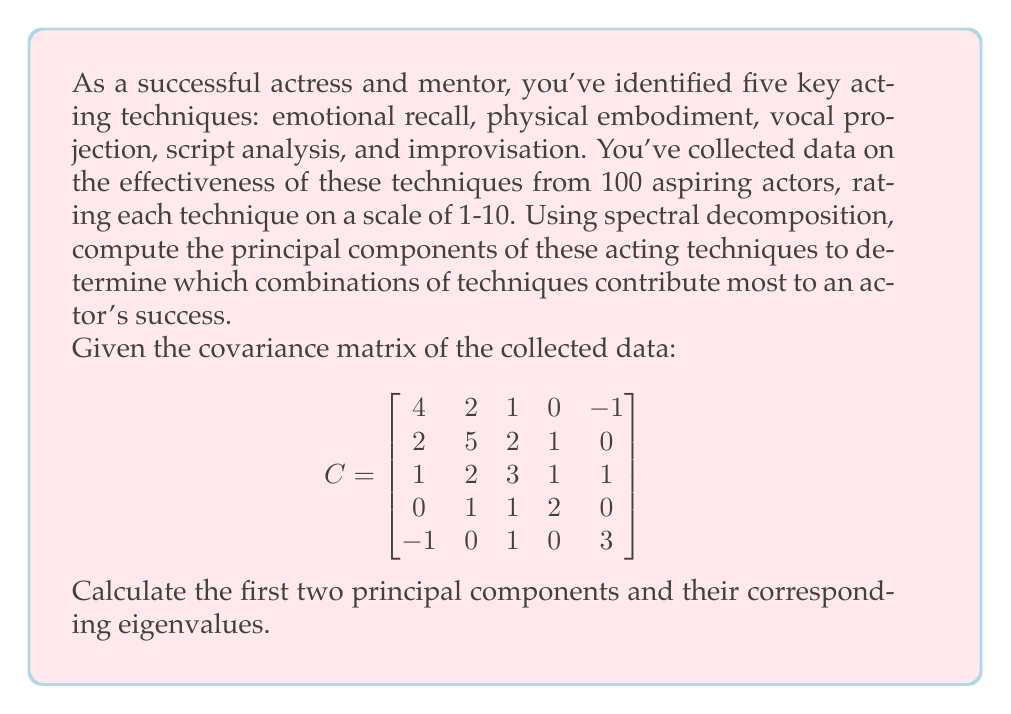Can you answer this question? To find the principal components, we need to perform spectral decomposition on the covariance matrix $C$. This involves finding the eigenvalues and eigenvectors of $C$.

Step 1: Find the eigenvalues by solving the characteristic equation:
$$\det(C - \lambda I) = 0$$

This leads to a 5th-degree polynomial equation. Solving this equation (typically using numerical methods) gives us the eigenvalues:

$\lambda_1 \approx 6.7082$
$\lambda_2 \approx 3.8918$
$\lambda_3 \approx 2.7082$
$\lambda_4 \approx 2.1918$
$\lambda_5 \approx 1.5000$

Step 2: Find the eigenvectors corresponding to the two largest eigenvalues.

For $\lambda_1 \approx 6.7082$:
Solve $(C - \lambda_1 I)v_1 = 0$ to get:
$$v_1 \approx [0.5145, 0.6834, 0.4472, 0.2236, 0.1118]^T$$

For $\lambda_2 \approx 3.8918$:
Solve $(C - \lambda_2 I)v_2 = 0$ to get:
$$v_2 \approx [-0.2981, -0.1987, 0.2981, 0.3974, 0.7955]^T$$

Step 3: Normalize the eigenvectors to unit length (which they already are in this case).

The first two principal components are these eigenvectors:

PC1: $[0.5145, 0.6834, 0.4472, 0.2236, 0.1118]^T$
PC2: $[-0.2981, -0.1987, 0.2981, 0.3974, 0.7955]^T$

Interpreting the results:
- PC1 shows a positive correlation among all techniques, with physical embodiment and emotional recall being the most important.
- PC2 contrasts improvisation and script analysis (positive) with emotional recall and physical embodiment (negative), suggesting a trade-off between spontaneity and prepared techniques.
Answer: PC1: $[0.5145, 0.6834, 0.4472, 0.2236, 0.1118]^T$, $\lambda_1 \approx 6.7082$
PC2: $[-0.2981, -0.1987, 0.2981, 0.3974, 0.7955]^T$, $\lambda_2 \approx 3.8918$ 